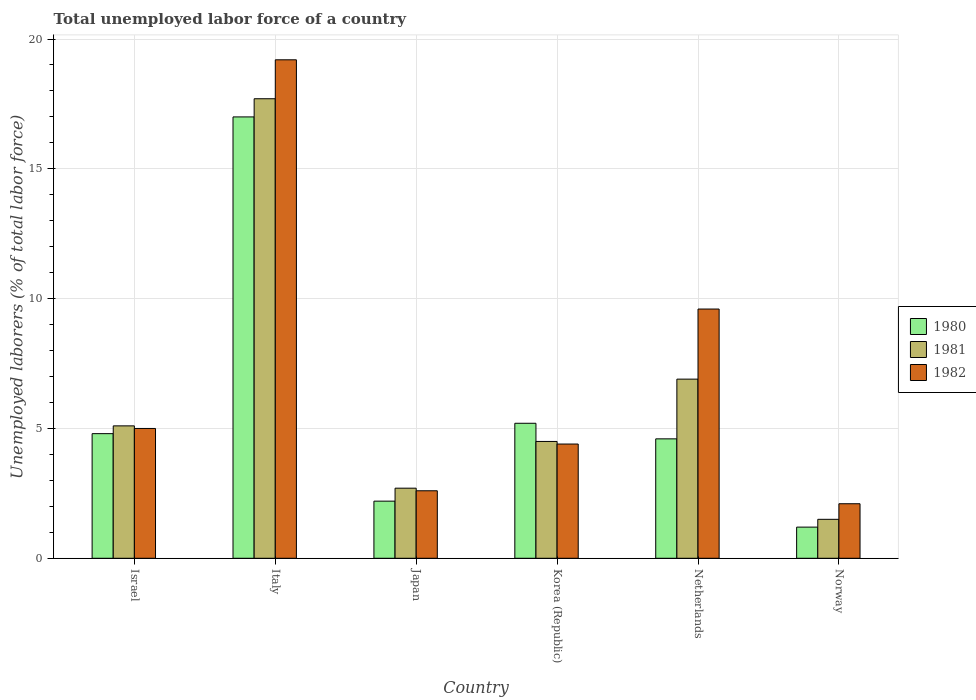How many groups of bars are there?
Offer a very short reply. 6. Are the number of bars per tick equal to the number of legend labels?
Make the answer very short. Yes. Are the number of bars on each tick of the X-axis equal?
Provide a succinct answer. Yes. What is the label of the 2nd group of bars from the left?
Make the answer very short. Italy. In how many cases, is the number of bars for a given country not equal to the number of legend labels?
Your response must be concise. 0. What is the total unemployed labor force in 1982 in Japan?
Provide a short and direct response. 2.6. Across all countries, what is the maximum total unemployed labor force in 1981?
Provide a short and direct response. 17.7. Across all countries, what is the minimum total unemployed labor force in 1980?
Give a very brief answer. 1.2. In which country was the total unemployed labor force in 1982 maximum?
Ensure brevity in your answer.  Italy. What is the total total unemployed labor force in 1981 in the graph?
Give a very brief answer. 38.4. What is the difference between the total unemployed labor force in 1982 in Netherlands and that in Norway?
Provide a succinct answer. 7.5. What is the difference between the total unemployed labor force in 1982 in Netherlands and the total unemployed labor force in 1981 in Israel?
Make the answer very short. 4.5. What is the average total unemployed labor force in 1980 per country?
Offer a very short reply. 5.83. What is the difference between the total unemployed labor force of/in 1981 and total unemployed labor force of/in 1982 in Netherlands?
Provide a short and direct response. -2.7. What is the ratio of the total unemployed labor force in 1980 in Netherlands to that in Norway?
Provide a succinct answer. 3.83. Is the total unemployed labor force in 1981 in Israel less than that in Korea (Republic)?
Give a very brief answer. No. Is the difference between the total unemployed labor force in 1981 in Japan and Korea (Republic) greater than the difference between the total unemployed labor force in 1982 in Japan and Korea (Republic)?
Provide a succinct answer. Yes. What is the difference between the highest and the second highest total unemployed labor force in 1982?
Offer a very short reply. -9.6. What is the difference between the highest and the lowest total unemployed labor force in 1982?
Give a very brief answer. 17.1. In how many countries, is the total unemployed labor force in 1981 greater than the average total unemployed labor force in 1981 taken over all countries?
Provide a succinct answer. 2. Is the sum of the total unemployed labor force in 1980 in Japan and Norway greater than the maximum total unemployed labor force in 1981 across all countries?
Your answer should be compact. No. Are all the bars in the graph horizontal?
Your response must be concise. No. How many countries are there in the graph?
Ensure brevity in your answer.  6. What is the difference between two consecutive major ticks on the Y-axis?
Your response must be concise. 5. Are the values on the major ticks of Y-axis written in scientific E-notation?
Make the answer very short. No. Does the graph contain grids?
Ensure brevity in your answer.  Yes. Where does the legend appear in the graph?
Your response must be concise. Center right. How are the legend labels stacked?
Your response must be concise. Vertical. What is the title of the graph?
Make the answer very short. Total unemployed labor force of a country. What is the label or title of the X-axis?
Offer a very short reply. Country. What is the label or title of the Y-axis?
Give a very brief answer. Unemployed laborers (% of total labor force). What is the Unemployed laborers (% of total labor force) of 1980 in Israel?
Offer a terse response. 4.8. What is the Unemployed laborers (% of total labor force) in 1981 in Israel?
Your answer should be compact. 5.1. What is the Unemployed laborers (% of total labor force) in 1981 in Italy?
Give a very brief answer. 17.7. What is the Unemployed laborers (% of total labor force) in 1982 in Italy?
Keep it short and to the point. 19.2. What is the Unemployed laborers (% of total labor force) in 1980 in Japan?
Make the answer very short. 2.2. What is the Unemployed laborers (% of total labor force) of 1981 in Japan?
Your answer should be very brief. 2.7. What is the Unemployed laborers (% of total labor force) of 1982 in Japan?
Ensure brevity in your answer.  2.6. What is the Unemployed laborers (% of total labor force) of 1980 in Korea (Republic)?
Your answer should be compact. 5.2. What is the Unemployed laborers (% of total labor force) in 1981 in Korea (Republic)?
Give a very brief answer. 4.5. What is the Unemployed laborers (% of total labor force) in 1982 in Korea (Republic)?
Your response must be concise. 4.4. What is the Unemployed laborers (% of total labor force) of 1980 in Netherlands?
Your response must be concise. 4.6. What is the Unemployed laborers (% of total labor force) of 1981 in Netherlands?
Your response must be concise. 6.9. What is the Unemployed laborers (% of total labor force) of 1982 in Netherlands?
Your response must be concise. 9.6. What is the Unemployed laborers (% of total labor force) of 1980 in Norway?
Make the answer very short. 1.2. What is the Unemployed laborers (% of total labor force) in 1981 in Norway?
Your answer should be very brief. 1.5. What is the Unemployed laborers (% of total labor force) in 1982 in Norway?
Offer a terse response. 2.1. Across all countries, what is the maximum Unemployed laborers (% of total labor force) in 1981?
Ensure brevity in your answer.  17.7. Across all countries, what is the maximum Unemployed laborers (% of total labor force) in 1982?
Your response must be concise. 19.2. Across all countries, what is the minimum Unemployed laborers (% of total labor force) in 1980?
Make the answer very short. 1.2. Across all countries, what is the minimum Unemployed laborers (% of total labor force) of 1981?
Keep it short and to the point. 1.5. Across all countries, what is the minimum Unemployed laborers (% of total labor force) in 1982?
Make the answer very short. 2.1. What is the total Unemployed laborers (% of total labor force) of 1981 in the graph?
Provide a short and direct response. 38.4. What is the total Unemployed laborers (% of total labor force) of 1982 in the graph?
Make the answer very short. 42.9. What is the difference between the Unemployed laborers (% of total labor force) of 1980 in Israel and that in Japan?
Your answer should be very brief. 2.6. What is the difference between the Unemployed laborers (% of total labor force) of 1980 in Israel and that in Korea (Republic)?
Your response must be concise. -0.4. What is the difference between the Unemployed laborers (% of total labor force) of 1982 in Israel and that in Korea (Republic)?
Keep it short and to the point. 0.6. What is the difference between the Unemployed laborers (% of total labor force) in 1980 in Israel and that in Netherlands?
Keep it short and to the point. 0.2. What is the difference between the Unemployed laborers (% of total labor force) of 1982 in Israel and that in Norway?
Your answer should be very brief. 2.9. What is the difference between the Unemployed laborers (% of total labor force) of 1980 in Italy and that in Japan?
Offer a very short reply. 14.8. What is the difference between the Unemployed laborers (% of total labor force) in 1982 in Italy and that in Korea (Republic)?
Offer a terse response. 14.8. What is the difference between the Unemployed laborers (% of total labor force) of 1981 in Italy and that in Netherlands?
Keep it short and to the point. 10.8. What is the difference between the Unemployed laborers (% of total labor force) of 1981 in Italy and that in Norway?
Give a very brief answer. 16.2. What is the difference between the Unemployed laborers (% of total labor force) in 1980 in Japan and that in Korea (Republic)?
Offer a terse response. -3. What is the difference between the Unemployed laborers (% of total labor force) of 1981 in Japan and that in Korea (Republic)?
Your answer should be compact. -1.8. What is the difference between the Unemployed laborers (% of total labor force) in 1982 in Japan and that in Korea (Republic)?
Provide a short and direct response. -1.8. What is the difference between the Unemployed laborers (% of total labor force) of 1980 in Japan and that in Netherlands?
Your answer should be very brief. -2.4. What is the difference between the Unemployed laborers (% of total labor force) in 1982 in Japan and that in Netherlands?
Provide a succinct answer. -7. What is the difference between the Unemployed laborers (% of total labor force) in 1982 in Japan and that in Norway?
Keep it short and to the point. 0.5. What is the difference between the Unemployed laborers (% of total labor force) in 1982 in Korea (Republic) and that in Netherlands?
Your response must be concise. -5.2. What is the difference between the Unemployed laborers (% of total labor force) of 1981 in Korea (Republic) and that in Norway?
Your response must be concise. 3. What is the difference between the Unemployed laborers (% of total labor force) of 1980 in Netherlands and that in Norway?
Ensure brevity in your answer.  3.4. What is the difference between the Unemployed laborers (% of total labor force) in 1981 in Netherlands and that in Norway?
Give a very brief answer. 5.4. What is the difference between the Unemployed laborers (% of total labor force) of 1980 in Israel and the Unemployed laborers (% of total labor force) of 1982 in Italy?
Your response must be concise. -14.4. What is the difference between the Unemployed laborers (% of total labor force) of 1981 in Israel and the Unemployed laborers (% of total labor force) of 1982 in Italy?
Ensure brevity in your answer.  -14.1. What is the difference between the Unemployed laborers (% of total labor force) in 1980 in Israel and the Unemployed laborers (% of total labor force) in 1981 in Japan?
Your answer should be compact. 2.1. What is the difference between the Unemployed laborers (% of total labor force) of 1980 in Israel and the Unemployed laborers (% of total labor force) of 1982 in Japan?
Your answer should be very brief. 2.2. What is the difference between the Unemployed laborers (% of total labor force) of 1981 in Israel and the Unemployed laborers (% of total labor force) of 1982 in Japan?
Make the answer very short. 2.5. What is the difference between the Unemployed laborers (% of total labor force) of 1980 in Israel and the Unemployed laborers (% of total labor force) of 1981 in Korea (Republic)?
Offer a terse response. 0.3. What is the difference between the Unemployed laborers (% of total labor force) in 1980 in Israel and the Unemployed laborers (% of total labor force) in 1981 in Netherlands?
Offer a terse response. -2.1. What is the difference between the Unemployed laborers (% of total labor force) in 1980 in Israel and the Unemployed laborers (% of total labor force) in 1982 in Netherlands?
Your response must be concise. -4.8. What is the difference between the Unemployed laborers (% of total labor force) in 1981 in Israel and the Unemployed laborers (% of total labor force) in 1982 in Netherlands?
Provide a short and direct response. -4.5. What is the difference between the Unemployed laborers (% of total labor force) in 1980 in Israel and the Unemployed laborers (% of total labor force) in 1981 in Norway?
Make the answer very short. 3.3. What is the difference between the Unemployed laborers (% of total labor force) of 1980 in Italy and the Unemployed laborers (% of total labor force) of 1981 in Japan?
Provide a succinct answer. 14.3. What is the difference between the Unemployed laborers (% of total labor force) in 1980 in Italy and the Unemployed laborers (% of total labor force) in 1982 in Japan?
Your answer should be very brief. 14.4. What is the difference between the Unemployed laborers (% of total labor force) in 1980 in Italy and the Unemployed laborers (% of total labor force) in 1982 in Korea (Republic)?
Your response must be concise. 12.6. What is the difference between the Unemployed laborers (% of total labor force) of 1980 in Italy and the Unemployed laborers (% of total labor force) of 1981 in Netherlands?
Ensure brevity in your answer.  10.1. What is the difference between the Unemployed laborers (% of total labor force) of 1980 in Italy and the Unemployed laborers (% of total labor force) of 1982 in Norway?
Provide a short and direct response. 14.9. What is the difference between the Unemployed laborers (% of total labor force) in 1981 in Japan and the Unemployed laborers (% of total labor force) in 1982 in Netherlands?
Provide a succinct answer. -6.9. What is the difference between the Unemployed laborers (% of total labor force) in 1980 in Japan and the Unemployed laborers (% of total labor force) in 1982 in Norway?
Your response must be concise. 0.1. What is the difference between the Unemployed laborers (% of total labor force) of 1981 in Korea (Republic) and the Unemployed laborers (% of total labor force) of 1982 in Netherlands?
Your response must be concise. -5.1. What is the difference between the Unemployed laborers (% of total labor force) in 1980 in Korea (Republic) and the Unemployed laborers (% of total labor force) in 1981 in Norway?
Make the answer very short. 3.7. What is the difference between the Unemployed laborers (% of total labor force) of 1980 in Korea (Republic) and the Unemployed laborers (% of total labor force) of 1982 in Norway?
Your response must be concise. 3.1. What is the difference between the Unemployed laborers (% of total labor force) in 1981 in Korea (Republic) and the Unemployed laborers (% of total labor force) in 1982 in Norway?
Your response must be concise. 2.4. What is the difference between the Unemployed laborers (% of total labor force) of 1981 in Netherlands and the Unemployed laborers (% of total labor force) of 1982 in Norway?
Make the answer very short. 4.8. What is the average Unemployed laborers (% of total labor force) in 1980 per country?
Provide a succinct answer. 5.83. What is the average Unemployed laborers (% of total labor force) in 1981 per country?
Your answer should be very brief. 6.4. What is the average Unemployed laborers (% of total labor force) of 1982 per country?
Provide a succinct answer. 7.15. What is the difference between the Unemployed laborers (% of total labor force) in 1980 and Unemployed laborers (% of total labor force) in 1981 in Israel?
Keep it short and to the point. -0.3. What is the difference between the Unemployed laborers (% of total labor force) in 1980 and Unemployed laborers (% of total labor force) in 1982 in Israel?
Offer a very short reply. -0.2. What is the difference between the Unemployed laborers (% of total labor force) in 1981 and Unemployed laborers (% of total labor force) in 1982 in Israel?
Your response must be concise. 0.1. What is the difference between the Unemployed laborers (% of total labor force) of 1981 and Unemployed laborers (% of total labor force) of 1982 in Italy?
Offer a very short reply. -1.5. What is the difference between the Unemployed laborers (% of total labor force) of 1980 and Unemployed laborers (% of total labor force) of 1982 in Japan?
Offer a very short reply. -0.4. What is the difference between the Unemployed laborers (% of total labor force) of 1981 and Unemployed laborers (% of total labor force) of 1982 in Japan?
Offer a terse response. 0.1. What is the difference between the Unemployed laborers (% of total labor force) of 1980 and Unemployed laborers (% of total labor force) of 1981 in Korea (Republic)?
Give a very brief answer. 0.7. What is the difference between the Unemployed laborers (% of total labor force) of 1980 and Unemployed laborers (% of total labor force) of 1982 in Korea (Republic)?
Provide a short and direct response. 0.8. What is the difference between the Unemployed laborers (% of total labor force) of 1981 and Unemployed laborers (% of total labor force) of 1982 in Korea (Republic)?
Ensure brevity in your answer.  0.1. What is the difference between the Unemployed laborers (% of total labor force) of 1980 and Unemployed laborers (% of total labor force) of 1981 in Netherlands?
Your response must be concise. -2.3. What is the difference between the Unemployed laborers (% of total labor force) in 1980 and Unemployed laborers (% of total labor force) in 1981 in Norway?
Your response must be concise. -0.3. What is the difference between the Unemployed laborers (% of total labor force) of 1980 and Unemployed laborers (% of total labor force) of 1982 in Norway?
Your answer should be very brief. -0.9. What is the ratio of the Unemployed laborers (% of total labor force) of 1980 in Israel to that in Italy?
Your answer should be very brief. 0.28. What is the ratio of the Unemployed laborers (% of total labor force) of 1981 in Israel to that in Italy?
Offer a very short reply. 0.29. What is the ratio of the Unemployed laborers (% of total labor force) in 1982 in Israel to that in Italy?
Offer a very short reply. 0.26. What is the ratio of the Unemployed laborers (% of total labor force) of 1980 in Israel to that in Japan?
Give a very brief answer. 2.18. What is the ratio of the Unemployed laborers (% of total labor force) of 1981 in Israel to that in Japan?
Ensure brevity in your answer.  1.89. What is the ratio of the Unemployed laborers (% of total labor force) of 1982 in Israel to that in Japan?
Offer a terse response. 1.92. What is the ratio of the Unemployed laborers (% of total labor force) of 1980 in Israel to that in Korea (Republic)?
Give a very brief answer. 0.92. What is the ratio of the Unemployed laborers (% of total labor force) in 1981 in Israel to that in Korea (Republic)?
Your response must be concise. 1.13. What is the ratio of the Unemployed laborers (% of total labor force) of 1982 in Israel to that in Korea (Republic)?
Provide a short and direct response. 1.14. What is the ratio of the Unemployed laborers (% of total labor force) in 1980 in Israel to that in Netherlands?
Provide a succinct answer. 1.04. What is the ratio of the Unemployed laborers (% of total labor force) in 1981 in Israel to that in Netherlands?
Your response must be concise. 0.74. What is the ratio of the Unemployed laborers (% of total labor force) in 1982 in Israel to that in Netherlands?
Provide a succinct answer. 0.52. What is the ratio of the Unemployed laborers (% of total labor force) of 1981 in Israel to that in Norway?
Give a very brief answer. 3.4. What is the ratio of the Unemployed laborers (% of total labor force) in 1982 in Israel to that in Norway?
Provide a short and direct response. 2.38. What is the ratio of the Unemployed laborers (% of total labor force) in 1980 in Italy to that in Japan?
Your response must be concise. 7.73. What is the ratio of the Unemployed laborers (% of total labor force) in 1981 in Italy to that in Japan?
Offer a terse response. 6.56. What is the ratio of the Unemployed laborers (% of total labor force) of 1982 in Italy to that in Japan?
Offer a very short reply. 7.38. What is the ratio of the Unemployed laborers (% of total labor force) in 1980 in Italy to that in Korea (Republic)?
Keep it short and to the point. 3.27. What is the ratio of the Unemployed laborers (% of total labor force) of 1981 in Italy to that in Korea (Republic)?
Your answer should be very brief. 3.93. What is the ratio of the Unemployed laborers (% of total labor force) of 1982 in Italy to that in Korea (Republic)?
Provide a succinct answer. 4.36. What is the ratio of the Unemployed laborers (% of total labor force) of 1980 in Italy to that in Netherlands?
Your response must be concise. 3.7. What is the ratio of the Unemployed laborers (% of total labor force) of 1981 in Italy to that in Netherlands?
Provide a short and direct response. 2.57. What is the ratio of the Unemployed laborers (% of total labor force) of 1982 in Italy to that in Netherlands?
Ensure brevity in your answer.  2. What is the ratio of the Unemployed laborers (% of total labor force) in 1980 in Italy to that in Norway?
Offer a terse response. 14.17. What is the ratio of the Unemployed laborers (% of total labor force) of 1981 in Italy to that in Norway?
Provide a short and direct response. 11.8. What is the ratio of the Unemployed laborers (% of total labor force) of 1982 in Italy to that in Norway?
Make the answer very short. 9.14. What is the ratio of the Unemployed laborers (% of total labor force) of 1980 in Japan to that in Korea (Republic)?
Keep it short and to the point. 0.42. What is the ratio of the Unemployed laborers (% of total labor force) of 1981 in Japan to that in Korea (Republic)?
Offer a very short reply. 0.6. What is the ratio of the Unemployed laborers (% of total labor force) in 1982 in Japan to that in Korea (Republic)?
Your answer should be very brief. 0.59. What is the ratio of the Unemployed laborers (% of total labor force) of 1980 in Japan to that in Netherlands?
Give a very brief answer. 0.48. What is the ratio of the Unemployed laborers (% of total labor force) in 1981 in Japan to that in Netherlands?
Give a very brief answer. 0.39. What is the ratio of the Unemployed laborers (% of total labor force) of 1982 in Japan to that in Netherlands?
Your response must be concise. 0.27. What is the ratio of the Unemployed laborers (% of total labor force) in 1980 in Japan to that in Norway?
Offer a terse response. 1.83. What is the ratio of the Unemployed laborers (% of total labor force) of 1982 in Japan to that in Norway?
Ensure brevity in your answer.  1.24. What is the ratio of the Unemployed laborers (% of total labor force) of 1980 in Korea (Republic) to that in Netherlands?
Provide a short and direct response. 1.13. What is the ratio of the Unemployed laborers (% of total labor force) of 1981 in Korea (Republic) to that in Netherlands?
Your response must be concise. 0.65. What is the ratio of the Unemployed laborers (% of total labor force) in 1982 in Korea (Republic) to that in Netherlands?
Make the answer very short. 0.46. What is the ratio of the Unemployed laborers (% of total labor force) of 1980 in Korea (Republic) to that in Norway?
Offer a terse response. 4.33. What is the ratio of the Unemployed laborers (% of total labor force) of 1982 in Korea (Republic) to that in Norway?
Offer a terse response. 2.1. What is the ratio of the Unemployed laborers (% of total labor force) in 1980 in Netherlands to that in Norway?
Provide a short and direct response. 3.83. What is the ratio of the Unemployed laborers (% of total labor force) in 1982 in Netherlands to that in Norway?
Your response must be concise. 4.57. What is the difference between the highest and the second highest Unemployed laborers (% of total labor force) of 1982?
Provide a succinct answer. 9.6. What is the difference between the highest and the lowest Unemployed laborers (% of total labor force) of 1981?
Provide a succinct answer. 16.2. What is the difference between the highest and the lowest Unemployed laborers (% of total labor force) of 1982?
Offer a terse response. 17.1. 